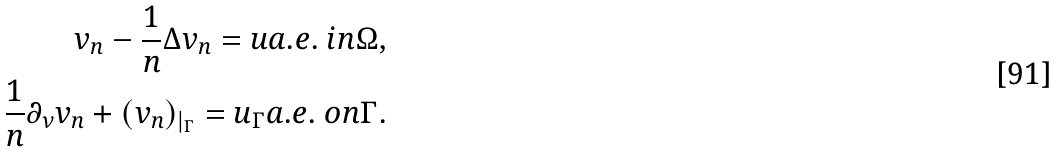<formula> <loc_0><loc_0><loc_500><loc_500>v _ { n } - \frac { 1 } { n } \Delta v _ { n } = u a . e . \ i n \Omega , \\ \frac { 1 } { n } \partial _ { \nu } v _ { n } + ( v _ { n } ) _ { | _ { \Gamma } } = u _ { \Gamma } a . e . \ o n \Gamma .</formula> 